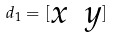<formula> <loc_0><loc_0><loc_500><loc_500>d _ { 1 } = [ \begin{matrix} x & y \\ \end{matrix} ]</formula> 